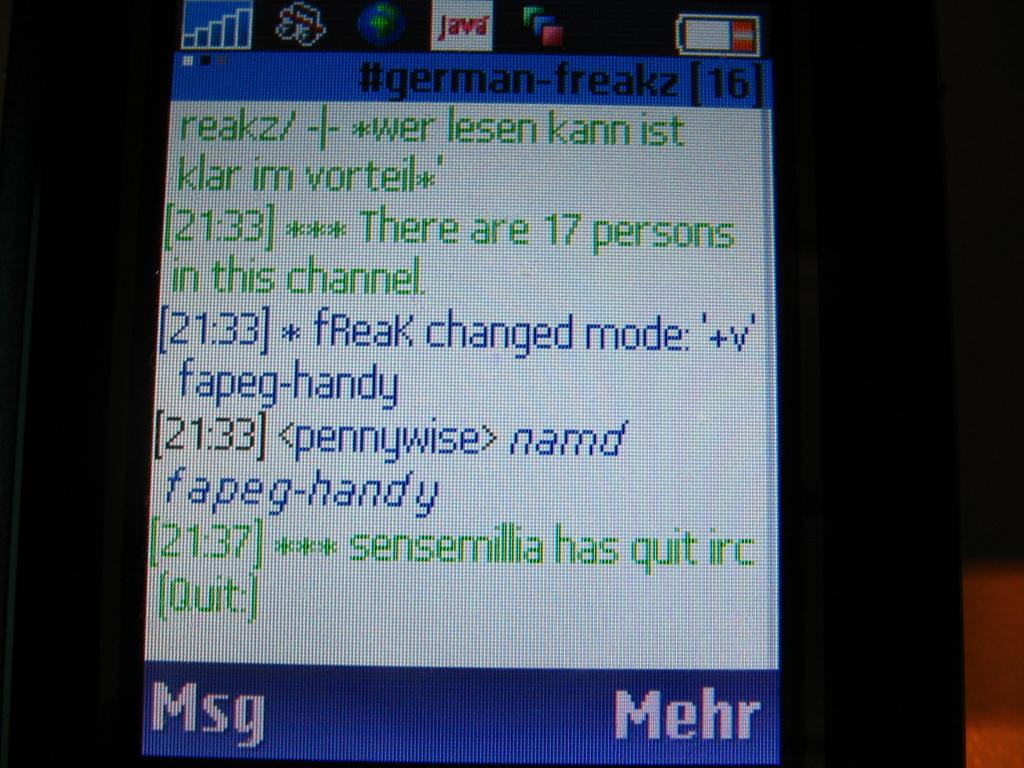Determine the number of people in the chanel?
Provide a short and direct response. 17. What program is shown on the screen?
Make the answer very short. Java. 